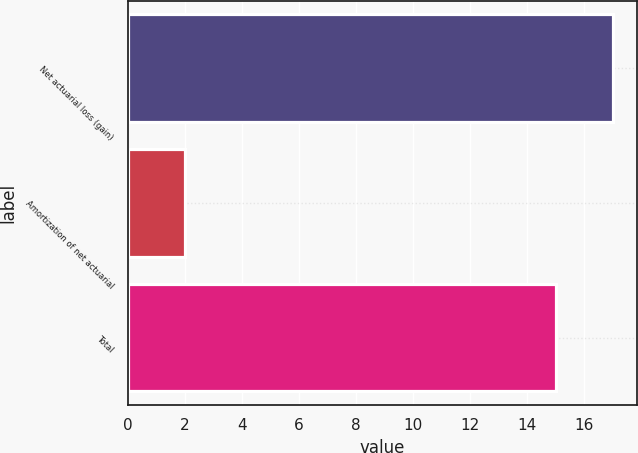<chart> <loc_0><loc_0><loc_500><loc_500><bar_chart><fcel>Net actuarial loss (gain)<fcel>Amortization of net actuarial<fcel>Total<nl><fcel>17<fcel>2<fcel>15<nl></chart> 